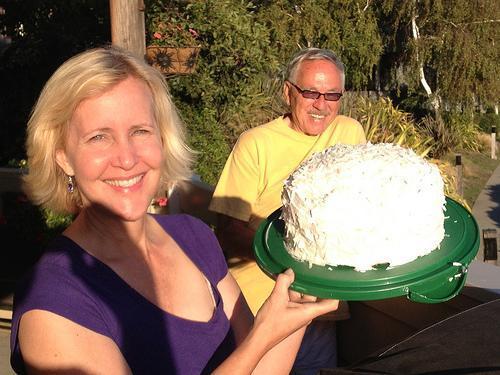How many cakes the woman is holding?
Give a very brief answer. 1. 